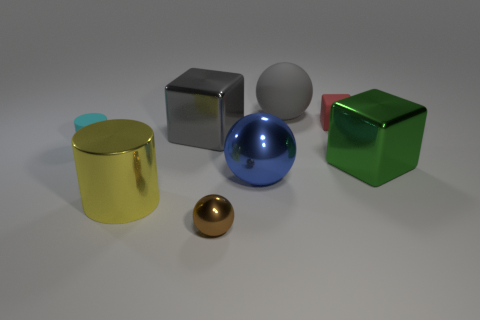Are there any rubber cubes that are on the right side of the large metallic object to the right of the large sphere in front of the cyan rubber cylinder?
Your answer should be very brief. No. What is the size of the ball behind the small cyan thing?
Keep it short and to the point. Large. What material is the green thing that is the same size as the yellow shiny object?
Keep it short and to the point. Metal. Does the yellow object have the same shape as the red matte thing?
Your answer should be very brief. No. How many things are either cubes or cylinders that are in front of the large green thing?
Give a very brief answer. 4. There is a shiny sphere that is on the left side of the blue thing; does it have the same size as the gray rubber sphere?
Give a very brief answer. No. There is a ball that is behind the cylinder that is on the left side of the big yellow thing; how many blue balls are behind it?
Your answer should be compact. 0. What number of yellow things are large cylinders or rubber blocks?
Ensure brevity in your answer.  1. What is the color of the cylinder that is made of the same material as the large gray cube?
Ensure brevity in your answer.  Yellow. How many small things are rubber cubes or blue balls?
Offer a terse response. 1. 